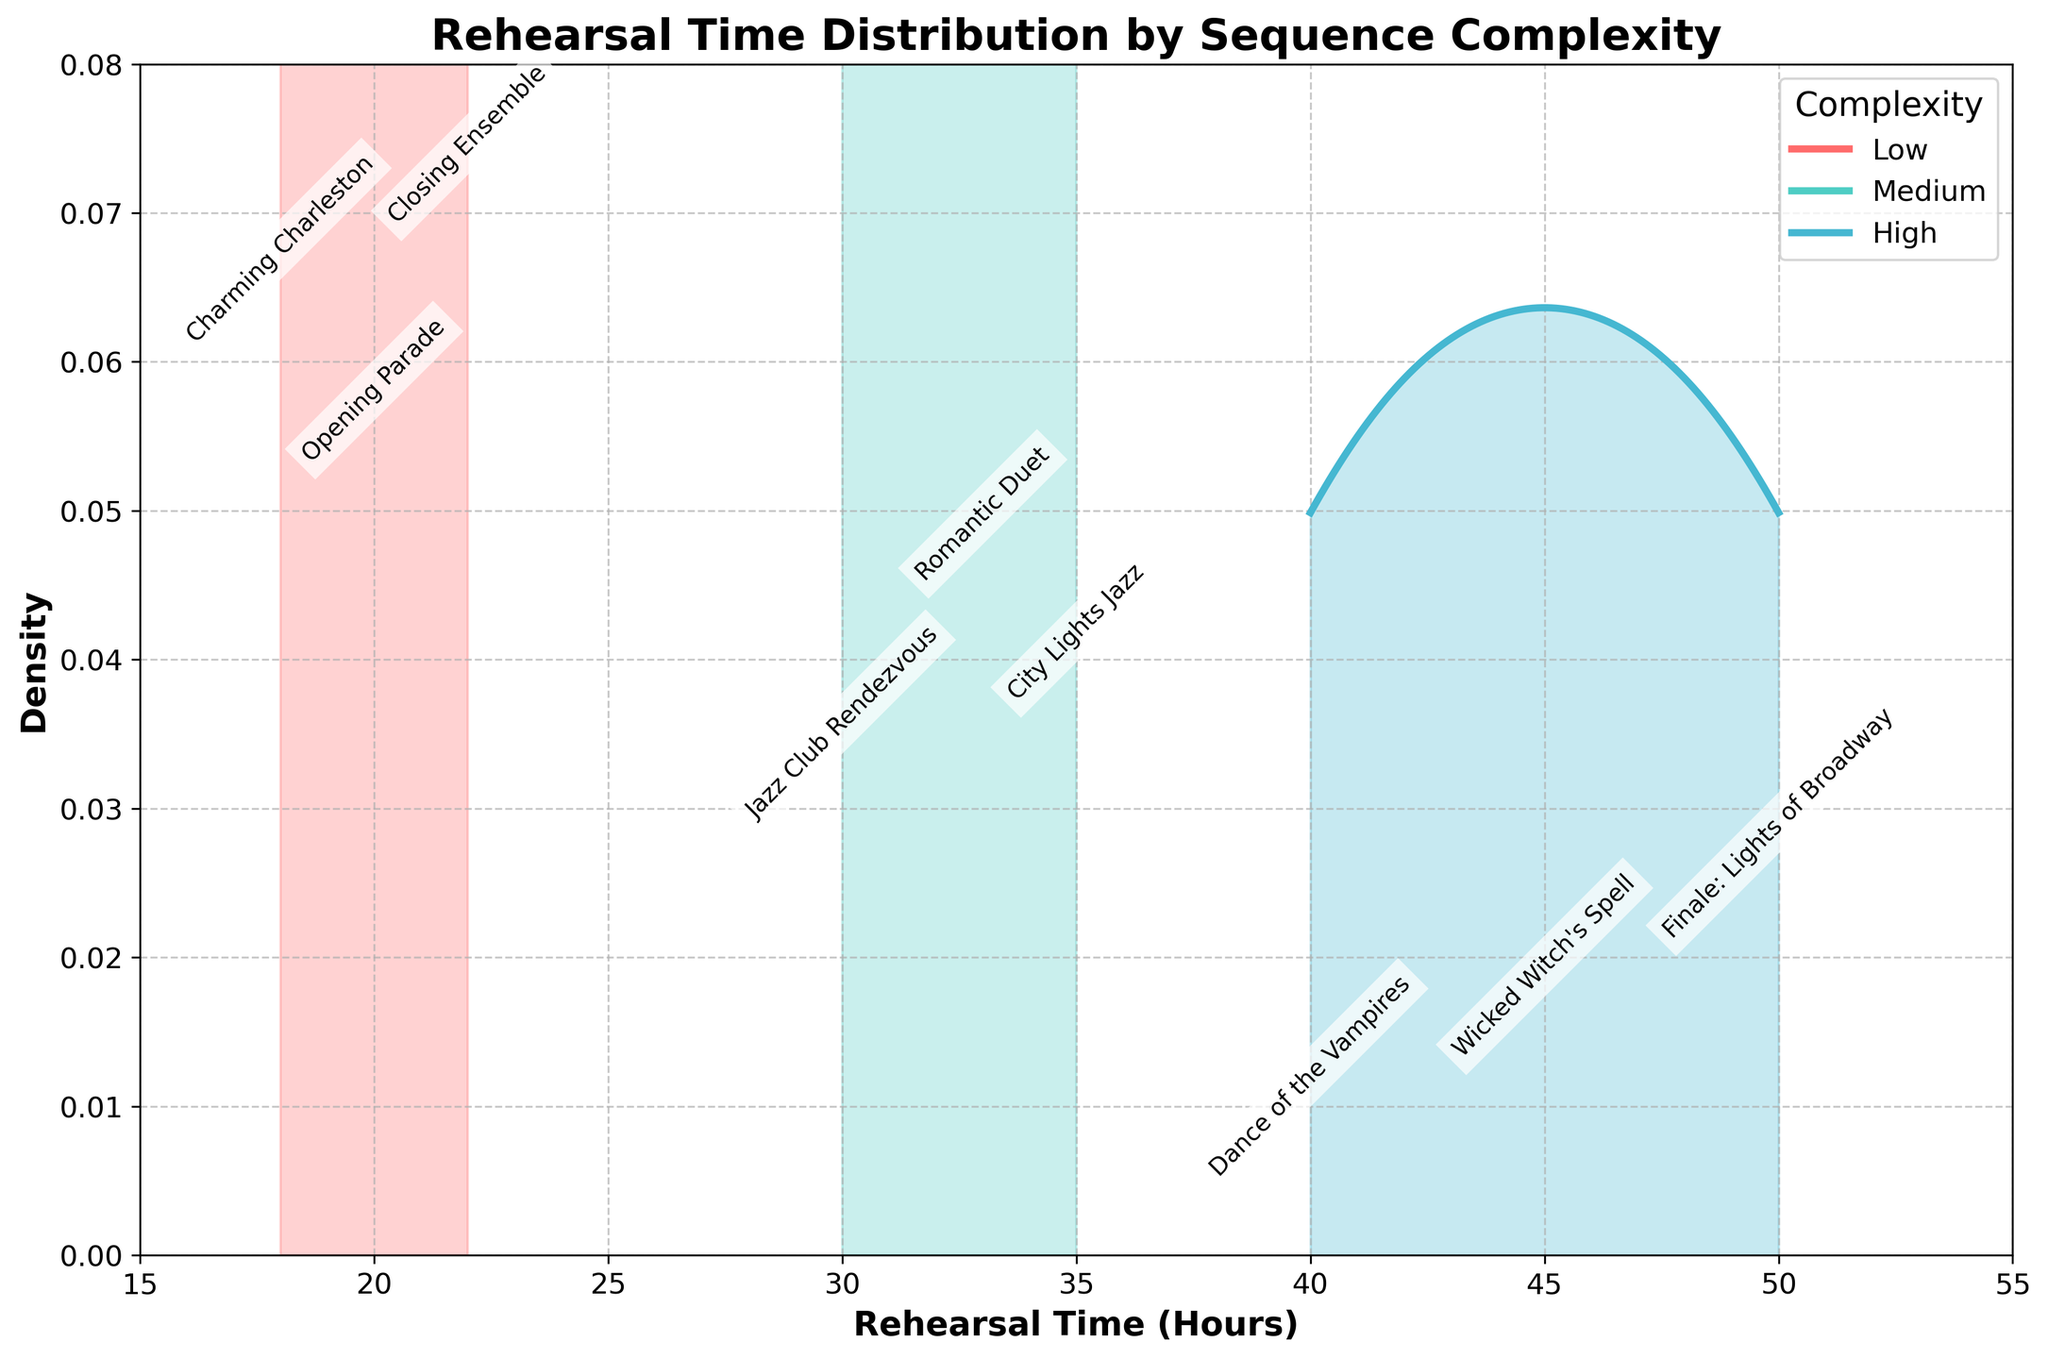What is the overall title of the density plot? The title is usually located at the top of the plot area, giving a summary of what the plot represents. In this case, it is clearly stated at the top.
Answer: "Rehearsal Time Distribution by Sequence Complexity" What range of rehearsal times is shown on the x-axis? The x-axis often displays the range of the independent variable. Looking at the x-axis from one end to the other, we see the span of rehearsal times.
Answer: 15 to 55 hours Which complexity level has the highest density peak? Look at the peaks of the density curves for Low, Medium, and High complexity levels and identify which one is the tallest.
Answer: High How many different dance sequences are represented in the plot? Each dance sequence is annotated along the x-axis, demonstrating the specific rehearsal times. Count these annotations to find the total number of sequences.
Answer: 9 Which dance sequence within the High complexity level has the longest rehearsal time? Within the High complexity level, identify which dance sequence's annotation is placed farthest to the right along the x-axis.
Answer: "Finale: Lights of Broadway" Comparing Medium and Low complexity levels, which one has a wider spread in rehearsal times? Look at the width of the density curves for both Medium and Low complexity levels. The wider curve indicates a wider spread of rehearsal times.
Answer: Medium How does the density of Low complexity compare to High complexity at a rehearsal time of 35 hours? Check the densities at 35 hours on the plot for both Low and High complexity levels. Observe and compare their heights.
Answer: Lower What is the approximate range of rehearsal times for Medium complexity dance sequences? Find the x-axis span covered by the density curve representing Medium complexity sequences.
Answer: 30 to 35 hours Which dance sequence has the shortest rehearsal time listed, and what is its complexity level? Look at the annotations along the x-axis and identify the earliest point. Check the listed sequence and its corresponding complexity level.
Answer: "Charming Charleston", Low Between Medium and High complexity levels, which one shows higher variability in rehearsal times? Variability can be inferred from the width and shape of the density curves. A more spread-out curve indicates higher variability. Compare the width and spread of Medium and High complexity curves.
Answer: High 